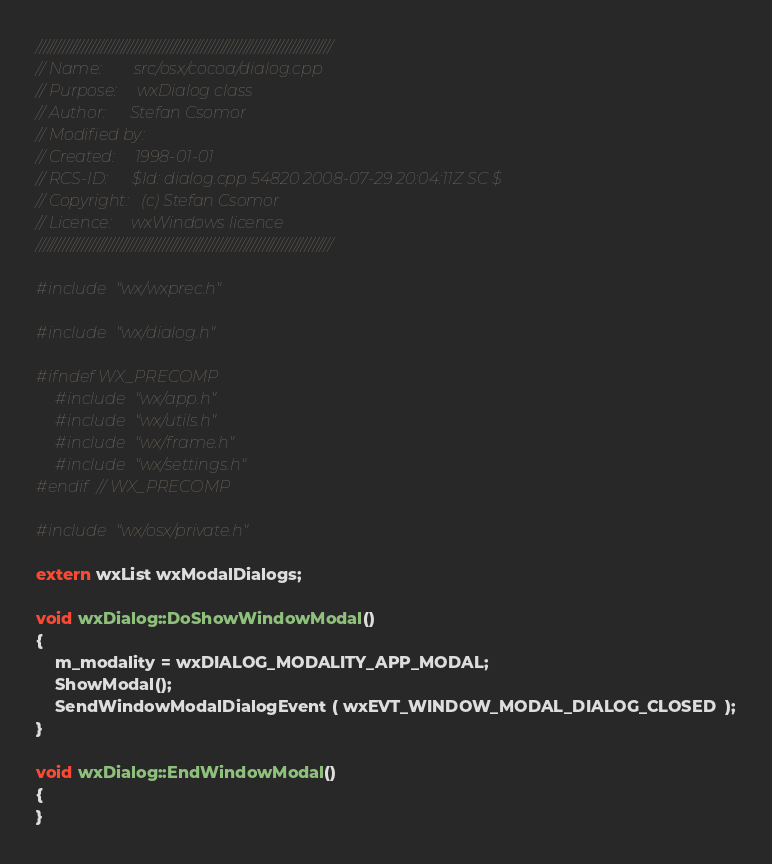Convert code to text. <code><loc_0><loc_0><loc_500><loc_500><_ObjectiveC_>/////////////////////////////////////////////////////////////////////////////
// Name:        src/osx/cocoa/dialog.cpp
// Purpose:     wxDialog class
// Author:      Stefan Csomor
// Modified by:
// Created:     1998-01-01
// RCS-ID:      $Id: dialog.cpp 54820 2008-07-29 20:04:11Z SC $
// Copyright:   (c) Stefan Csomor
// Licence:     wxWindows licence
/////////////////////////////////////////////////////////////////////////////

#include "wx/wxprec.h"

#include "wx/dialog.h"

#ifndef WX_PRECOMP
    #include "wx/app.h"
    #include "wx/utils.h"
    #include "wx/frame.h"
    #include "wx/settings.h"
#endif // WX_PRECOMP

#include "wx/osx/private.h"

extern wxList wxModalDialogs;

void wxDialog::DoShowWindowModal()
{   
    m_modality = wxDIALOG_MODALITY_APP_MODAL;
    ShowModal();
    SendWindowModalDialogEvent ( wxEVT_WINDOW_MODAL_DIALOG_CLOSED  );
}

void wxDialog::EndWindowModal()
{
}
</code> 